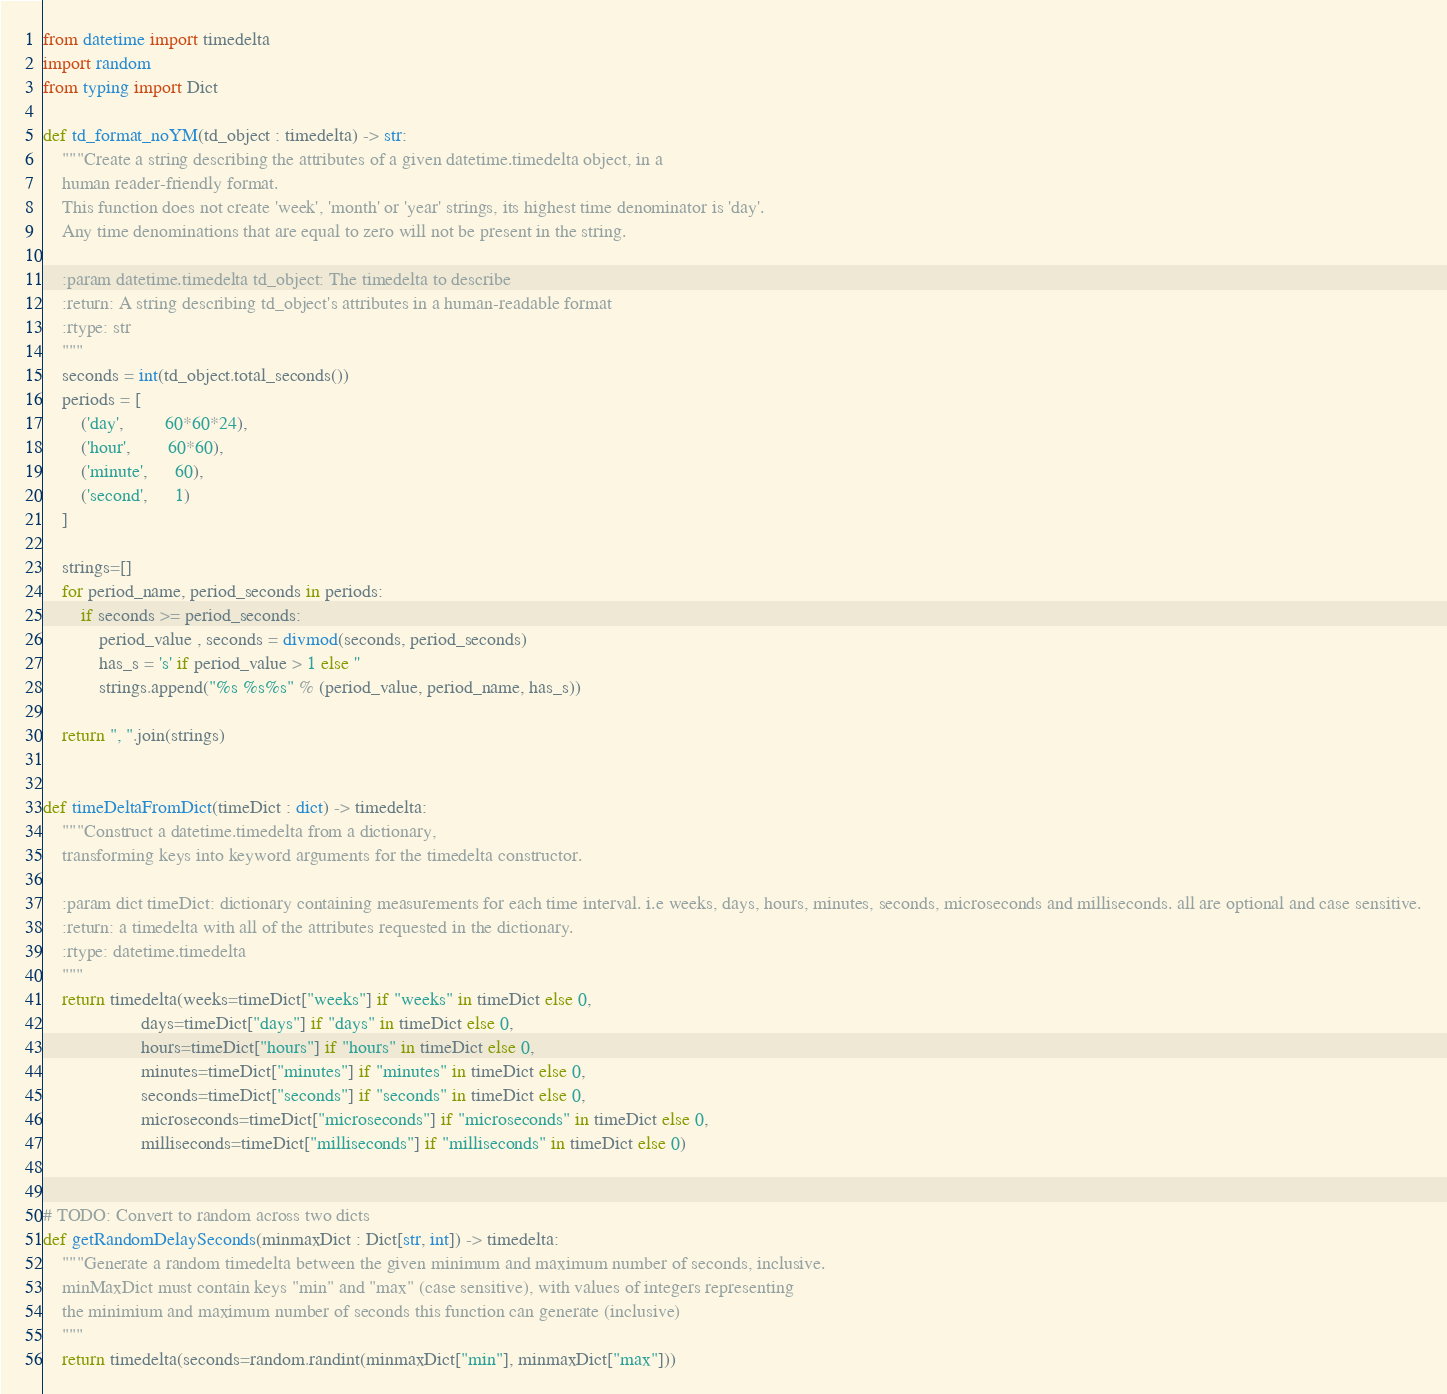<code> <loc_0><loc_0><loc_500><loc_500><_Python_>from datetime import timedelta
import random
from typing import Dict

def td_format_noYM(td_object : timedelta) -> str:
    """Create a string describing the attributes of a given datetime.timedelta object, in a
    human reader-friendly format.
    This function does not create 'week', 'month' or 'year' strings, its highest time denominator is 'day'.
    Any time denominations that are equal to zero will not be present in the string.

    :param datetime.timedelta td_object: The timedelta to describe
    :return: A string describing td_object's attributes in a human-readable format
    :rtype: str
    """
    seconds = int(td_object.total_seconds())
    periods = [
        ('day',         60*60*24),
        ('hour',        60*60),
        ('minute',      60),
        ('second',      1)
    ]

    strings=[]
    for period_name, period_seconds in periods:
        if seconds >= period_seconds:
            period_value , seconds = divmod(seconds, period_seconds)
            has_s = 's' if period_value > 1 else ''
            strings.append("%s %s%s" % (period_value, period_name, has_s))

    return ", ".join(strings)


def timeDeltaFromDict(timeDict : dict) -> timedelta:
    """Construct a datetime.timedelta from a dictionary,
    transforming keys into keyword arguments for the timedelta constructor.

    :param dict timeDict: dictionary containing measurements for each time interval. i.e weeks, days, hours, minutes, seconds, microseconds and milliseconds. all are optional and case sensitive.
    :return: a timedelta with all of the attributes requested in the dictionary.
    :rtype: datetime.timedelta
    """
    return timedelta(weeks=timeDict["weeks"] if "weeks" in timeDict else 0,
                     days=timeDict["days"] if "days" in timeDict else 0,
                     hours=timeDict["hours"] if "hours" in timeDict else 0,
                     minutes=timeDict["minutes"] if "minutes" in timeDict else 0,
                     seconds=timeDict["seconds"] if "seconds" in timeDict else 0,
                     microseconds=timeDict["microseconds"] if "microseconds" in timeDict else 0,
                     milliseconds=timeDict["milliseconds"] if "milliseconds" in timeDict else 0)


# TODO: Convert to random across two dicts
def getRandomDelaySeconds(minmaxDict : Dict[str, int]) -> timedelta:
    """Generate a random timedelta between the given minimum and maximum number of seconds, inclusive.
    minMaxDict must contain keys "min" and "max" (case sensitive), with values of integers representing
    the minimium and maximum number of seconds this function can generate (inclusive)
    """
    return timedelta(seconds=random.randint(minmaxDict["min"], minmaxDict["max"]))</code> 